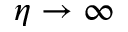<formula> <loc_0><loc_0><loc_500><loc_500>\eta \rightarrow \infty</formula> 